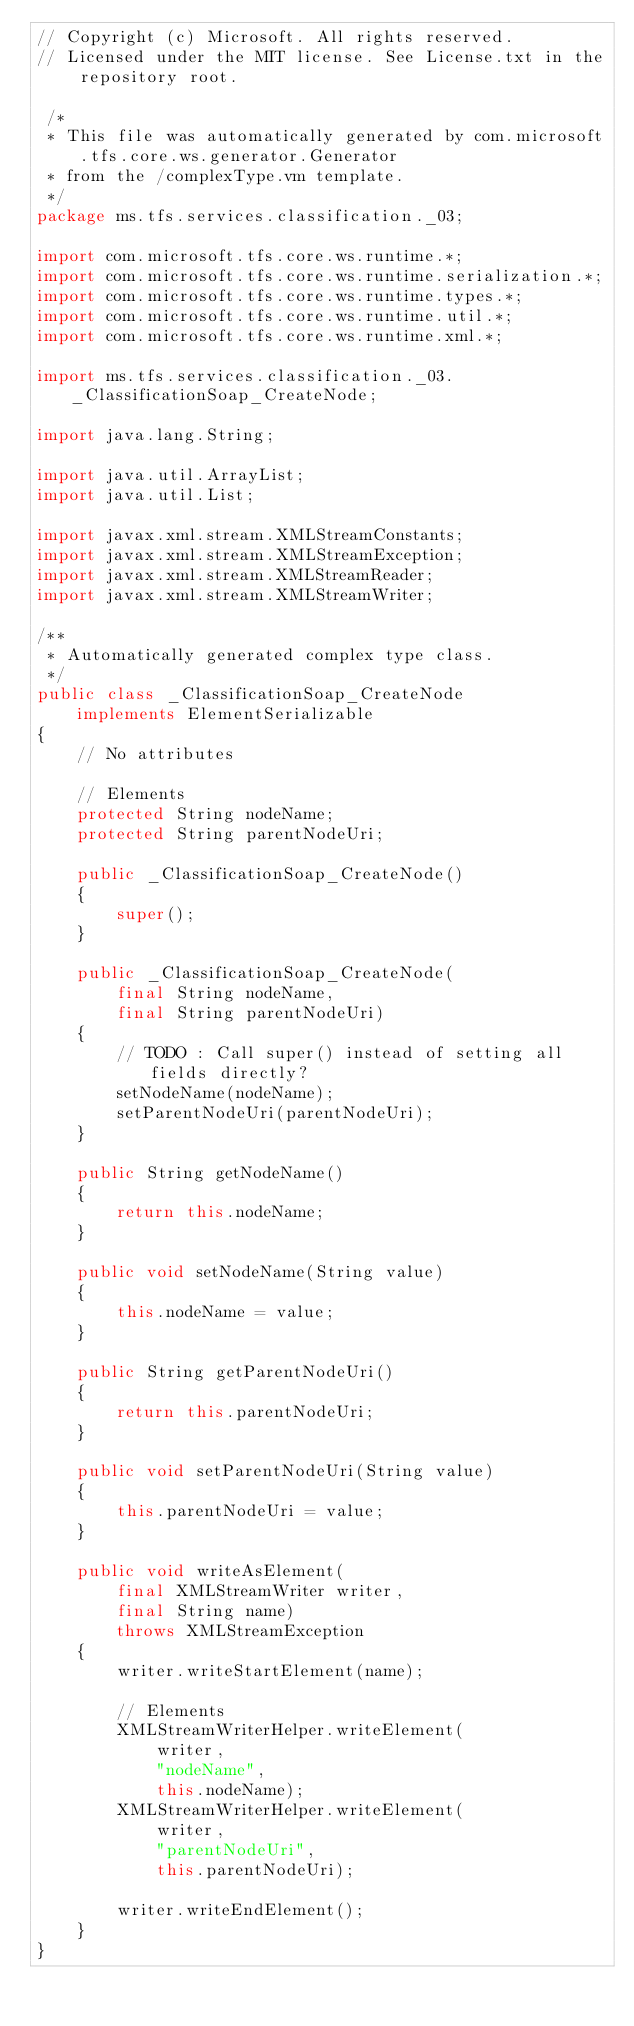<code> <loc_0><loc_0><loc_500><loc_500><_Java_>// Copyright (c) Microsoft. All rights reserved.
// Licensed under the MIT license. See License.txt in the repository root.

 /*
 * This file was automatically generated by com.microsoft.tfs.core.ws.generator.Generator
 * from the /complexType.vm template.
 */
package ms.tfs.services.classification._03;

import com.microsoft.tfs.core.ws.runtime.*;
import com.microsoft.tfs.core.ws.runtime.serialization.*;
import com.microsoft.tfs.core.ws.runtime.types.*;
import com.microsoft.tfs.core.ws.runtime.util.*;
import com.microsoft.tfs.core.ws.runtime.xml.*;

import ms.tfs.services.classification._03._ClassificationSoap_CreateNode;

import java.lang.String;

import java.util.ArrayList;
import java.util.List;

import javax.xml.stream.XMLStreamConstants;
import javax.xml.stream.XMLStreamException;
import javax.xml.stream.XMLStreamReader;
import javax.xml.stream.XMLStreamWriter;

/**
 * Automatically generated complex type class.
 */
public class _ClassificationSoap_CreateNode
    implements ElementSerializable
{
    // No attributes    

    // Elements
    protected String nodeName;
    protected String parentNodeUri;

    public _ClassificationSoap_CreateNode()
    {
        super();
    }

    public _ClassificationSoap_CreateNode(
        final String nodeName,
        final String parentNodeUri)
    {
        // TODO : Call super() instead of setting all fields directly?
        setNodeName(nodeName);
        setParentNodeUri(parentNodeUri);
    }

    public String getNodeName()
    {
        return this.nodeName;
    }

    public void setNodeName(String value)
    {
        this.nodeName = value;
    }

    public String getParentNodeUri()
    {
        return this.parentNodeUri;
    }

    public void setParentNodeUri(String value)
    {
        this.parentNodeUri = value;
    }

    public void writeAsElement(
        final XMLStreamWriter writer,
        final String name)
        throws XMLStreamException
    {
        writer.writeStartElement(name);

        // Elements
        XMLStreamWriterHelper.writeElement(
            writer,
            "nodeName",
            this.nodeName);
        XMLStreamWriterHelper.writeElement(
            writer,
            "parentNodeUri",
            this.parentNodeUri);

        writer.writeEndElement();
    }
}
</code> 